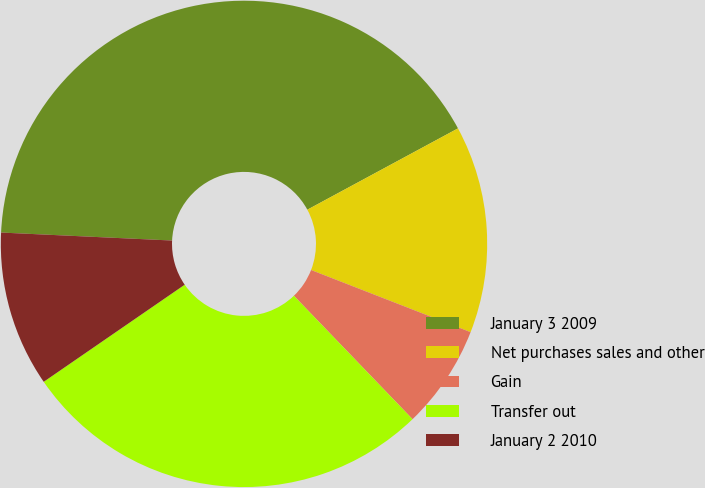<chart> <loc_0><loc_0><loc_500><loc_500><pie_chart><fcel>January 3 2009<fcel>Net purchases sales and other<fcel>Gain<fcel>Transfer out<fcel>January 2 2010<nl><fcel>41.38%<fcel>13.79%<fcel>6.9%<fcel>27.59%<fcel>10.34%<nl></chart> 